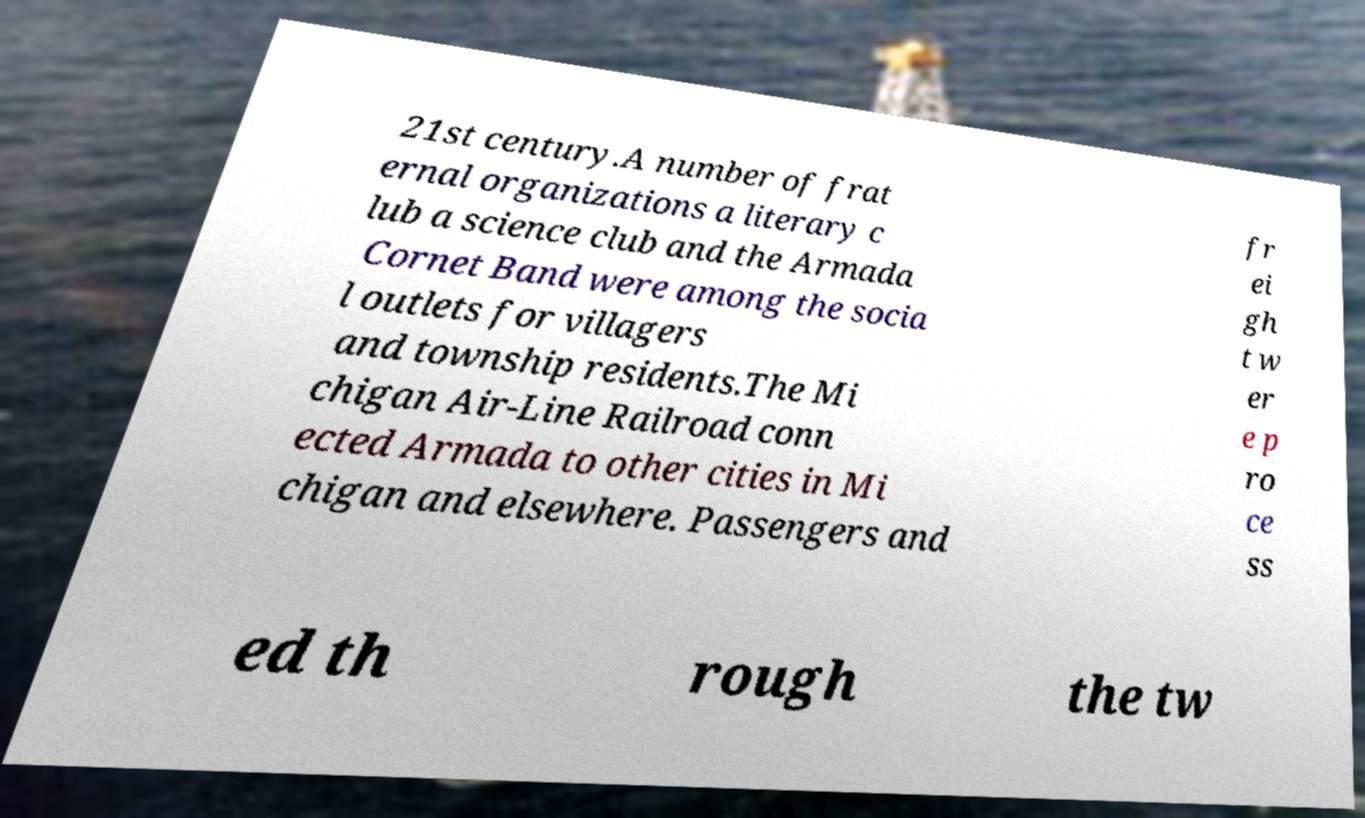What messages or text are displayed in this image? I need them in a readable, typed format. 21st century.A number of frat ernal organizations a literary c lub a science club and the Armada Cornet Band were among the socia l outlets for villagers and township residents.The Mi chigan Air-Line Railroad conn ected Armada to other cities in Mi chigan and elsewhere. Passengers and fr ei gh t w er e p ro ce ss ed th rough the tw 